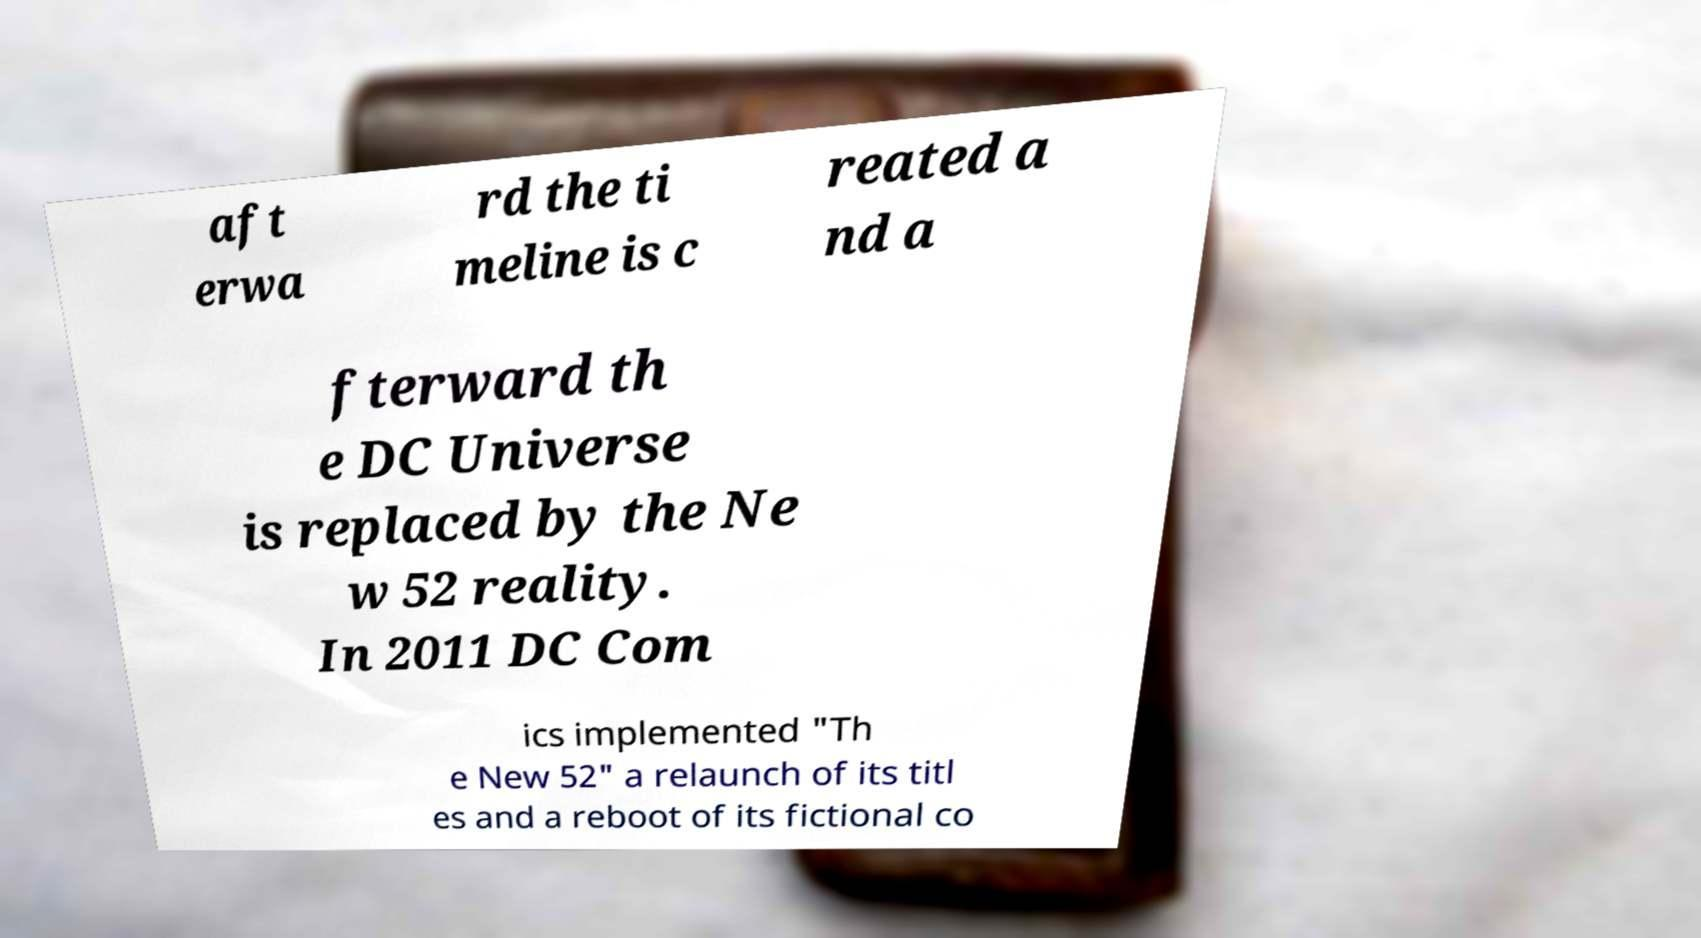Can you read and provide the text displayed in the image?This photo seems to have some interesting text. Can you extract and type it out for me? aft erwa rd the ti meline is c reated a nd a fterward th e DC Universe is replaced by the Ne w 52 reality. In 2011 DC Com ics implemented "Th e New 52" a relaunch of its titl es and a reboot of its fictional co 